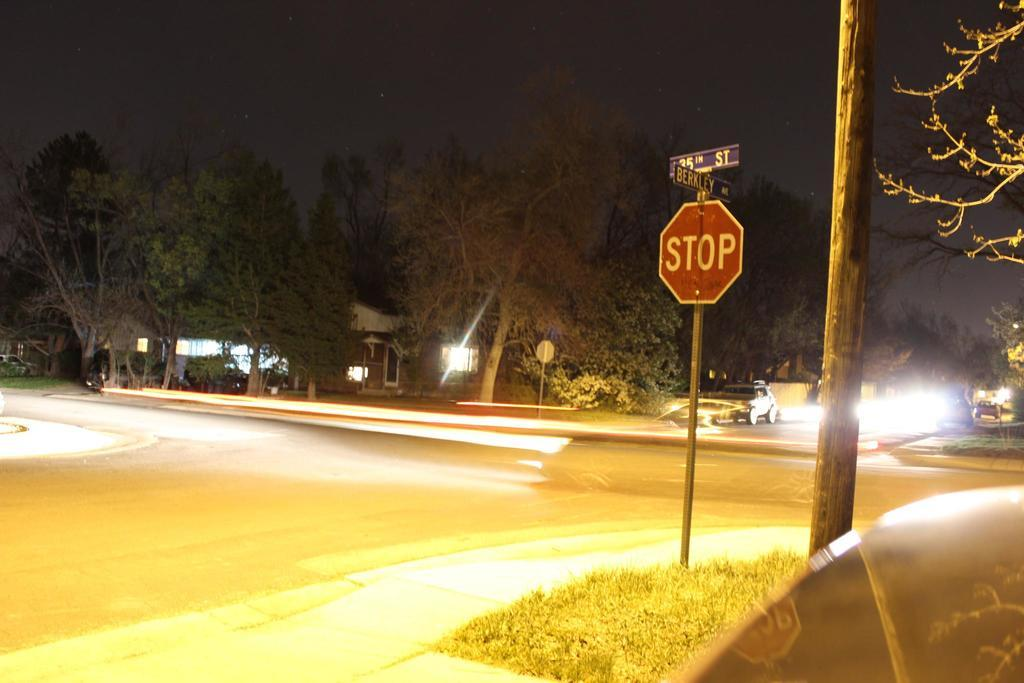<image>
Render a clear and concise summary of the photo. The road above the stop sign is Berkley Ave 